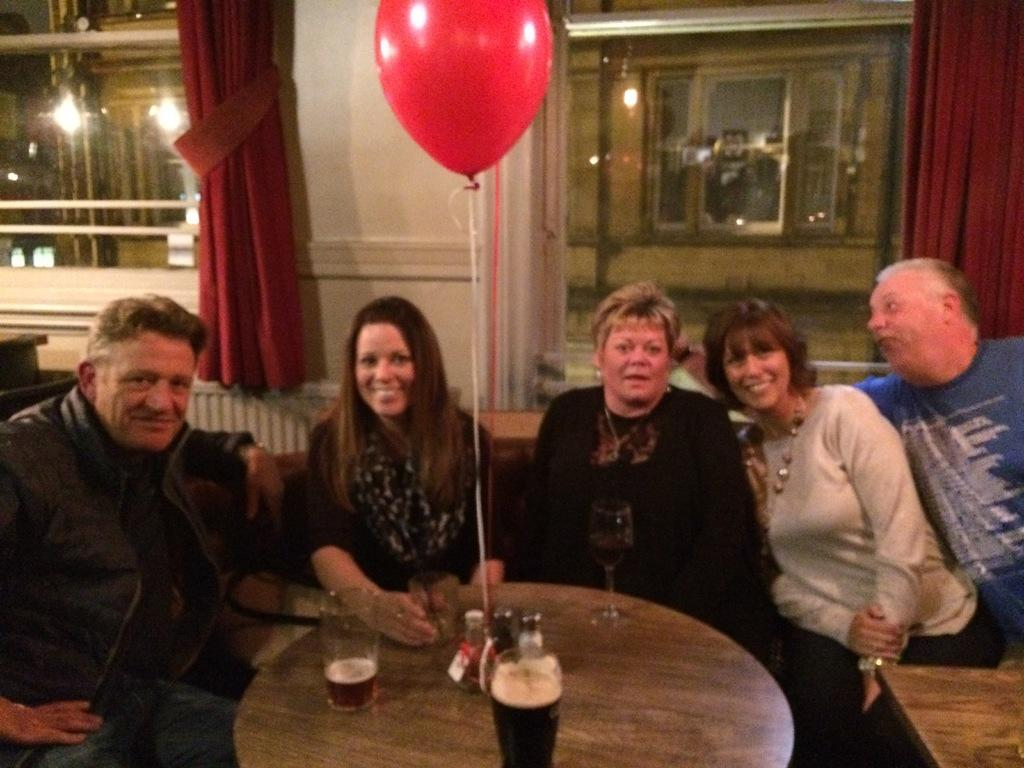How many people are in the image? There is a group of people in the image. What are the people doing in the image? The people are seated on chairs. What can be seen on the table in the image? There are glasses on the table and a balloon hanging on it. What type of window treatment is present in the image? There are curtains associated with the windows. What type of fruit is being cooked in the oven in the image? There is no oven or fruit present in the image. 